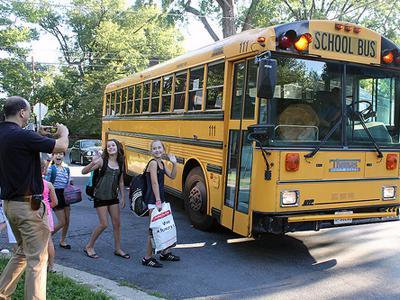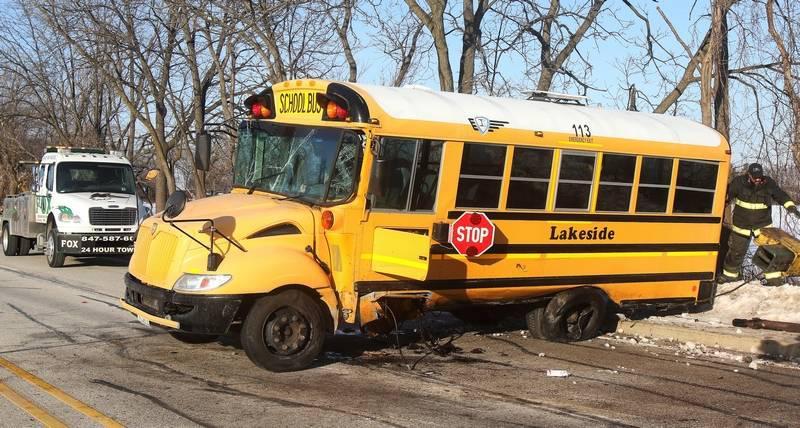The first image is the image on the left, the second image is the image on the right. Considering the images on both sides, is "People are standing outside near a bus in the image on the left." valid? Answer yes or no. Yes. The first image is the image on the left, the second image is the image on the right. Analyze the images presented: Is the assertion "There are one or more people next to the school bus in one image, but not the other." valid? Answer yes or no. Yes. 